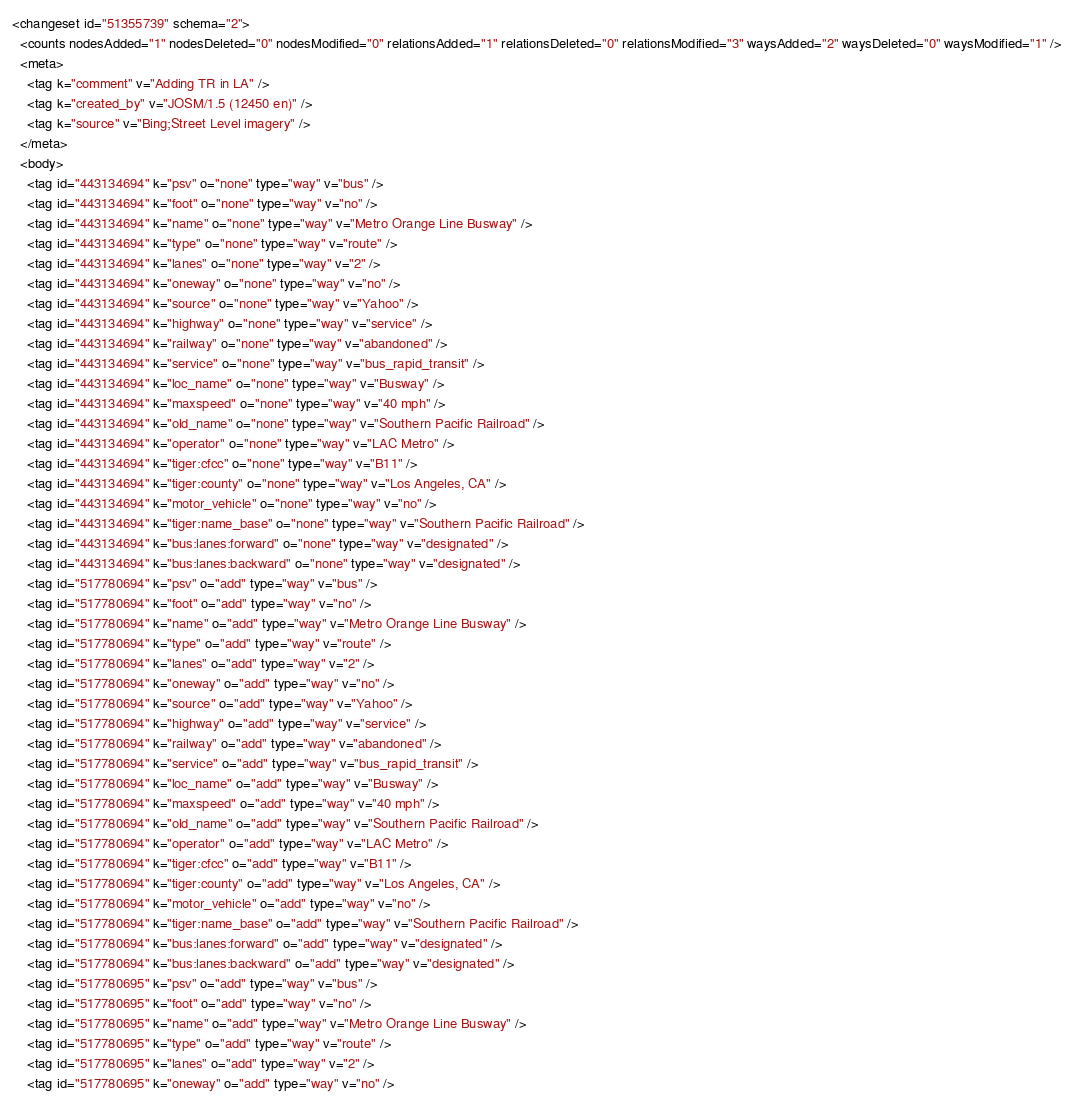<code> <loc_0><loc_0><loc_500><loc_500><_XML_><changeset id="51355739" schema="2">
  <counts nodesAdded="1" nodesDeleted="0" nodesModified="0" relationsAdded="1" relationsDeleted="0" relationsModified="3" waysAdded="2" waysDeleted="0" waysModified="1" />
  <meta>
    <tag k="comment" v="Adding TR in LA" />
    <tag k="created_by" v="JOSM/1.5 (12450 en)" />
    <tag k="source" v="Bing;Street Level imagery" />
  </meta>
  <body>
    <tag id="443134694" k="psv" o="none" type="way" v="bus" />
    <tag id="443134694" k="foot" o="none" type="way" v="no" />
    <tag id="443134694" k="name" o="none" type="way" v="Metro Orange Line Busway" />
    <tag id="443134694" k="type" o="none" type="way" v="route" />
    <tag id="443134694" k="lanes" o="none" type="way" v="2" />
    <tag id="443134694" k="oneway" o="none" type="way" v="no" />
    <tag id="443134694" k="source" o="none" type="way" v="Yahoo" />
    <tag id="443134694" k="highway" o="none" type="way" v="service" />
    <tag id="443134694" k="railway" o="none" type="way" v="abandoned" />
    <tag id="443134694" k="service" o="none" type="way" v="bus_rapid_transit" />
    <tag id="443134694" k="loc_name" o="none" type="way" v="Busway" />
    <tag id="443134694" k="maxspeed" o="none" type="way" v="40 mph" />
    <tag id="443134694" k="old_name" o="none" type="way" v="Southern Pacific Railroad" />
    <tag id="443134694" k="operator" o="none" type="way" v="LAC Metro" />
    <tag id="443134694" k="tiger:cfcc" o="none" type="way" v="B11" />
    <tag id="443134694" k="tiger:county" o="none" type="way" v="Los Angeles, CA" />
    <tag id="443134694" k="motor_vehicle" o="none" type="way" v="no" />
    <tag id="443134694" k="tiger:name_base" o="none" type="way" v="Southern Pacific Railroad" />
    <tag id="443134694" k="bus:lanes:forward" o="none" type="way" v="designated" />
    <tag id="443134694" k="bus:lanes:backward" o="none" type="way" v="designated" />
    <tag id="517780694" k="psv" o="add" type="way" v="bus" />
    <tag id="517780694" k="foot" o="add" type="way" v="no" />
    <tag id="517780694" k="name" o="add" type="way" v="Metro Orange Line Busway" />
    <tag id="517780694" k="type" o="add" type="way" v="route" />
    <tag id="517780694" k="lanes" o="add" type="way" v="2" />
    <tag id="517780694" k="oneway" o="add" type="way" v="no" />
    <tag id="517780694" k="source" o="add" type="way" v="Yahoo" />
    <tag id="517780694" k="highway" o="add" type="way" v="service" />
    <tag id="517780694" k="railway" o="add" type="way" v="abandoned" />
    <tag id="517780694" k="service" o="add" type="way" v="bus_rapid_transit" />
    <tag id="517780694" k="loc_name" o="add" type="way" v="Busway" />
    <tag id="517780694" k="maxspeed" o="add" type="way" v="40 mph" />
    <tag id="517780694" k="old_name" o="add" type="way" v="Southern Pacific Railroad" />
    <tag id="517780694" k="operator" o="add" type="way" v="LAC Metro" />
    <tag id="517780694" k="tiger:cfcc" o="add" type="way" v="B11" />
    <tag id="517780694" k="tiger:county" o="add" type="way" v="Los Angeles, CA" />
    <tag id="517780694" k="motor_vehicle" o="add" type="way" v="no" />
    <tag id="517780694" k="tiger:name_base" o="add" type="way" v="Southern Pacific Railroad" />
    <tag id="517780694" k="bus:lanes:forward" o="add" type="way" v="designated" />
    <tag id="517780694" k="bus:lanes:backward" o="add" type="way" v="designated" />
    <tag id="517780695" k="psv" o="add" type="way" v="bus" />
    <tag id="517780695" k="foot" o="add" type="way" v="no" />
    <tag id="517780695" k="name" o="add" type="way" v="Metro Orange Line Busway" />
    <tag id="517780695" k="type" o="add" type="way" v="route" />
    <tag id="517780695" k="lanes" o="add" type="way" v="2" />
    <tag id="517780695" k="oneway" o="add" type="way" v="no" /></code> 